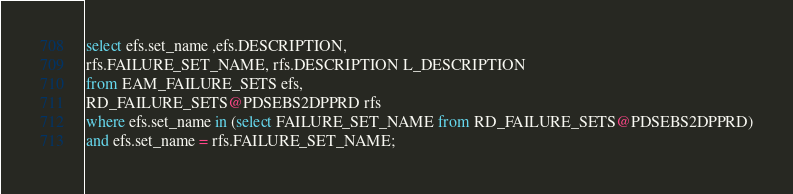<code> <loc_0><loc_0><loc_500><loc_500><_SQL_>select efs.set_name ,efs.DESCRIPTION,
rfs.FAILURE_SET_NAME, rfs.DESCRIPTION L_DESCRIPTION
from EAM_FAILURE_SETS efs,
RD_FAILURE_SETS@PDSEBS2DPPRD rfs
where efs.set_name in (select FAILURE_SET_NAME from RD_FAILURE_SETS@PDSEBS2DPPRD)
and efs.set_name = rfs.FAILURE_SET_NAME;
</code> 